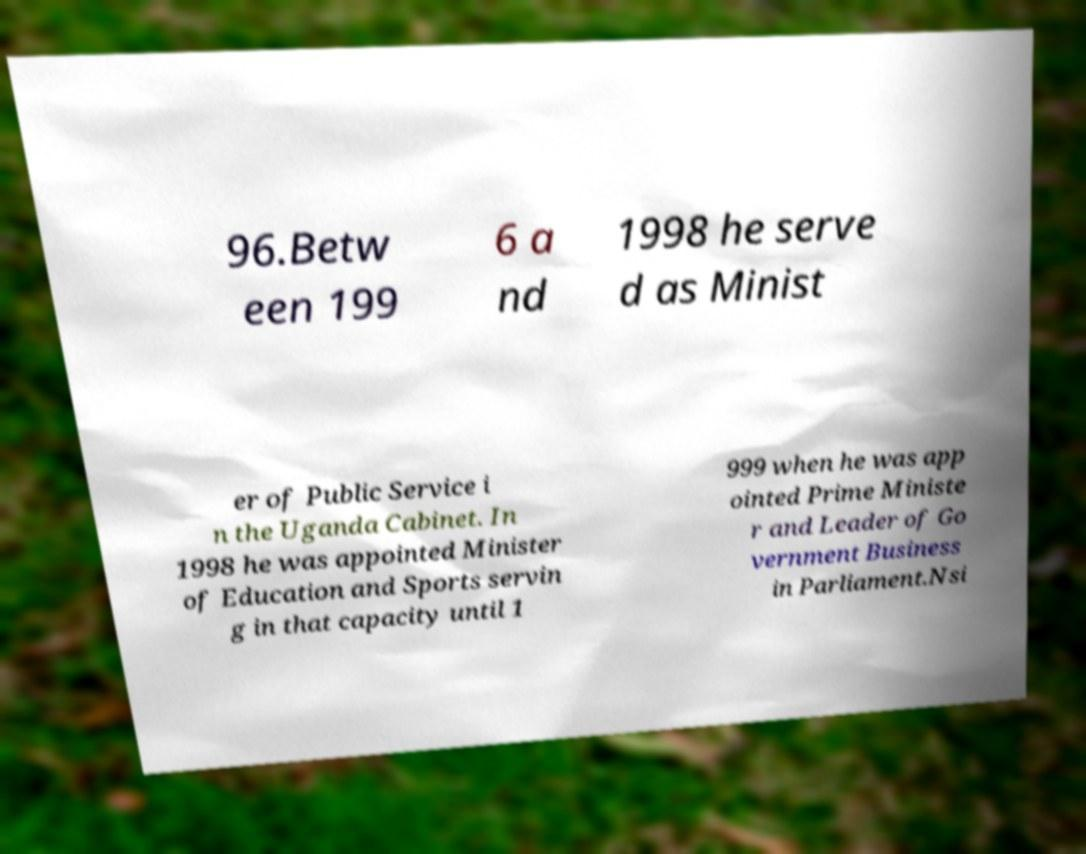I need the written content from this picture converted into text. Can you do that? 96.Betw een 199 6 a nd 1998 he serve d as Minist er of Public Service i n the Uganda Cabinet. In 1998 he was appointed Minister of Education and Sports servin g in that capacity until 1 999 when he was app ointed Prime Ministe r and Leader of Go vernment Business in Parliament.Nsi 